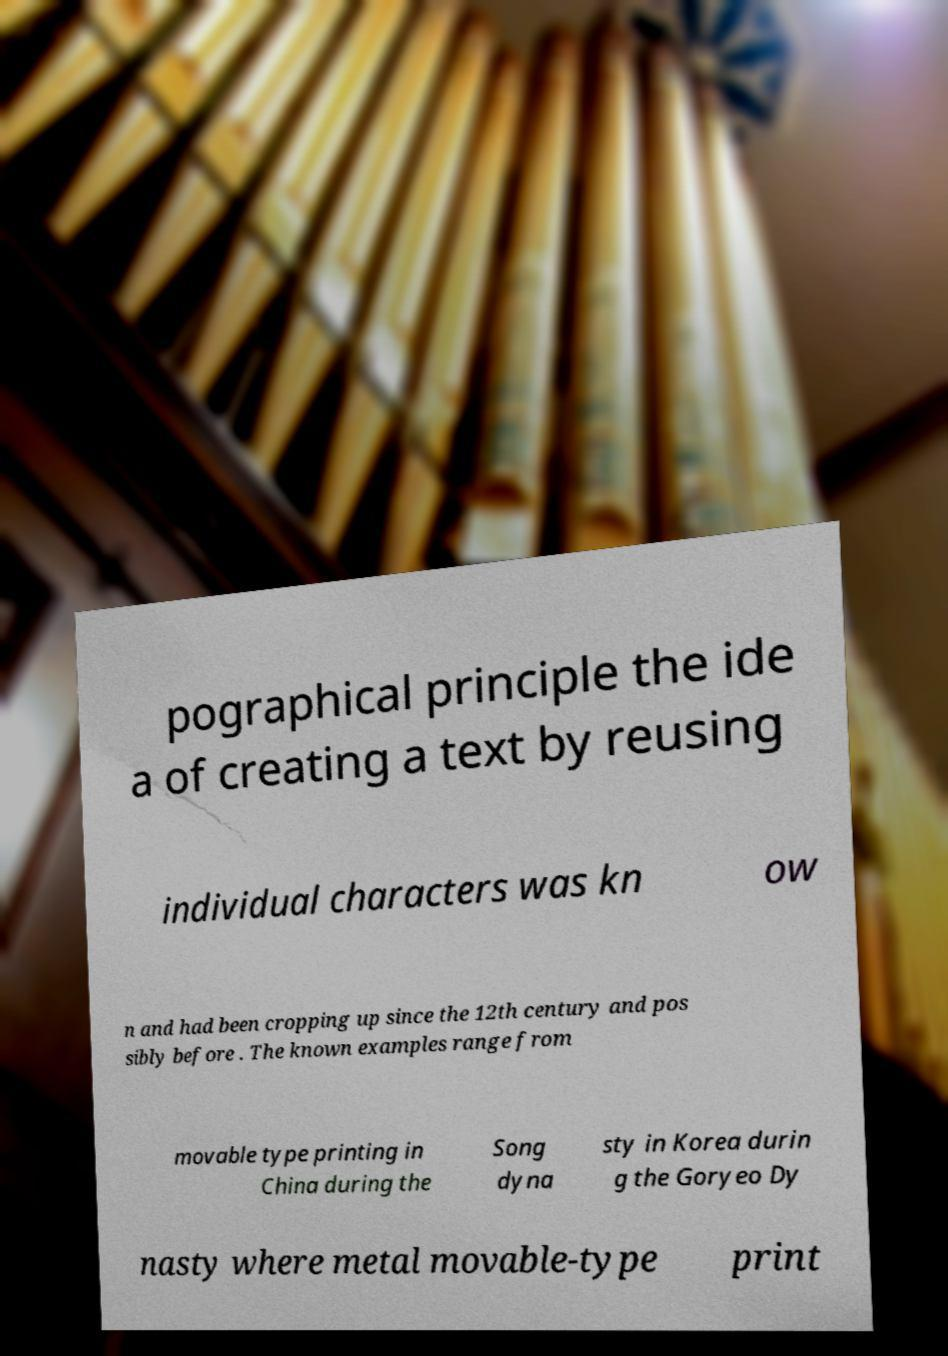Please read and relay the text visible in this image. What does it say? pographical principle the ide a of creating a text by reusing individual characters was kn ow n and had been cropping up since the 12th century and pos sibly before . The known examples range from movable type printing in China during the Song dyna sty in Korea durin g the Goryeo Dy nasty where metal movable-type print 